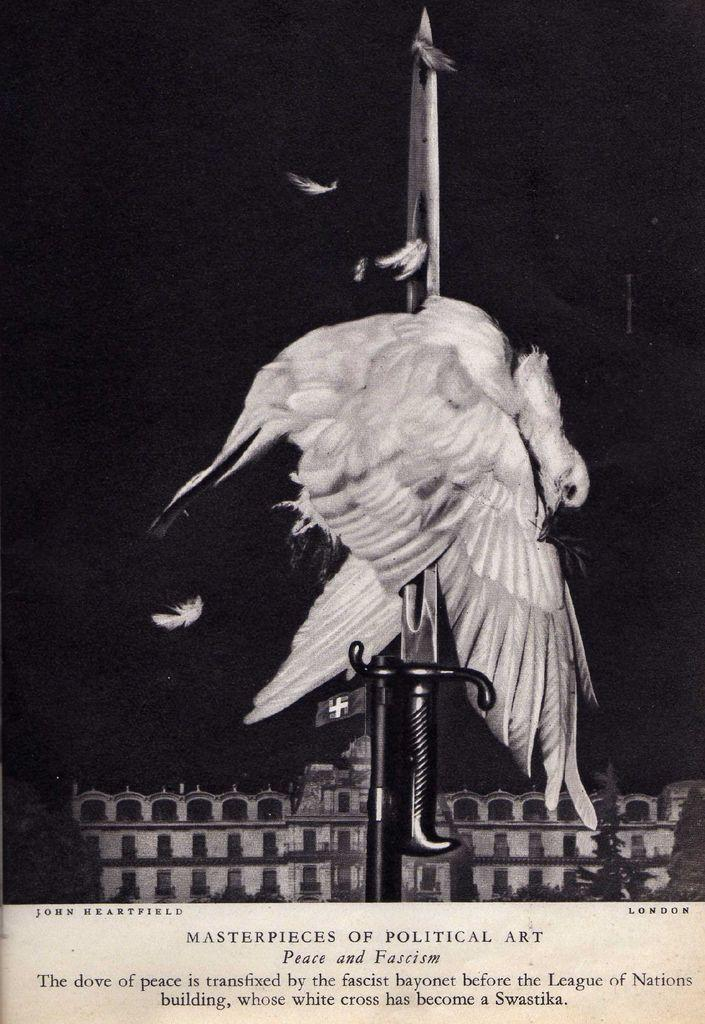<image>
Present a compact description of the photo's key features. a picture of one of the masterpieces of political art called 'peace and fassicm' 